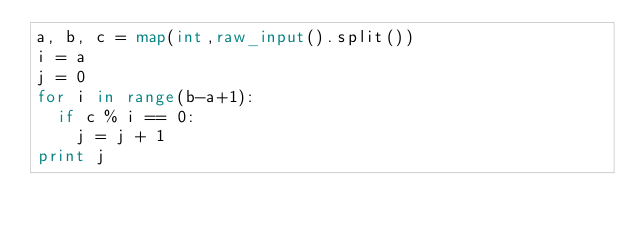<code> <loc_0><loc_0><loc_500><loc_500><_Python_>a, b, c = map(int,raw_input().split())
i = a
j = 0
for i in range(b-a+1):
  if c % i == 0:
    j = j + 1
print j
    </code> 